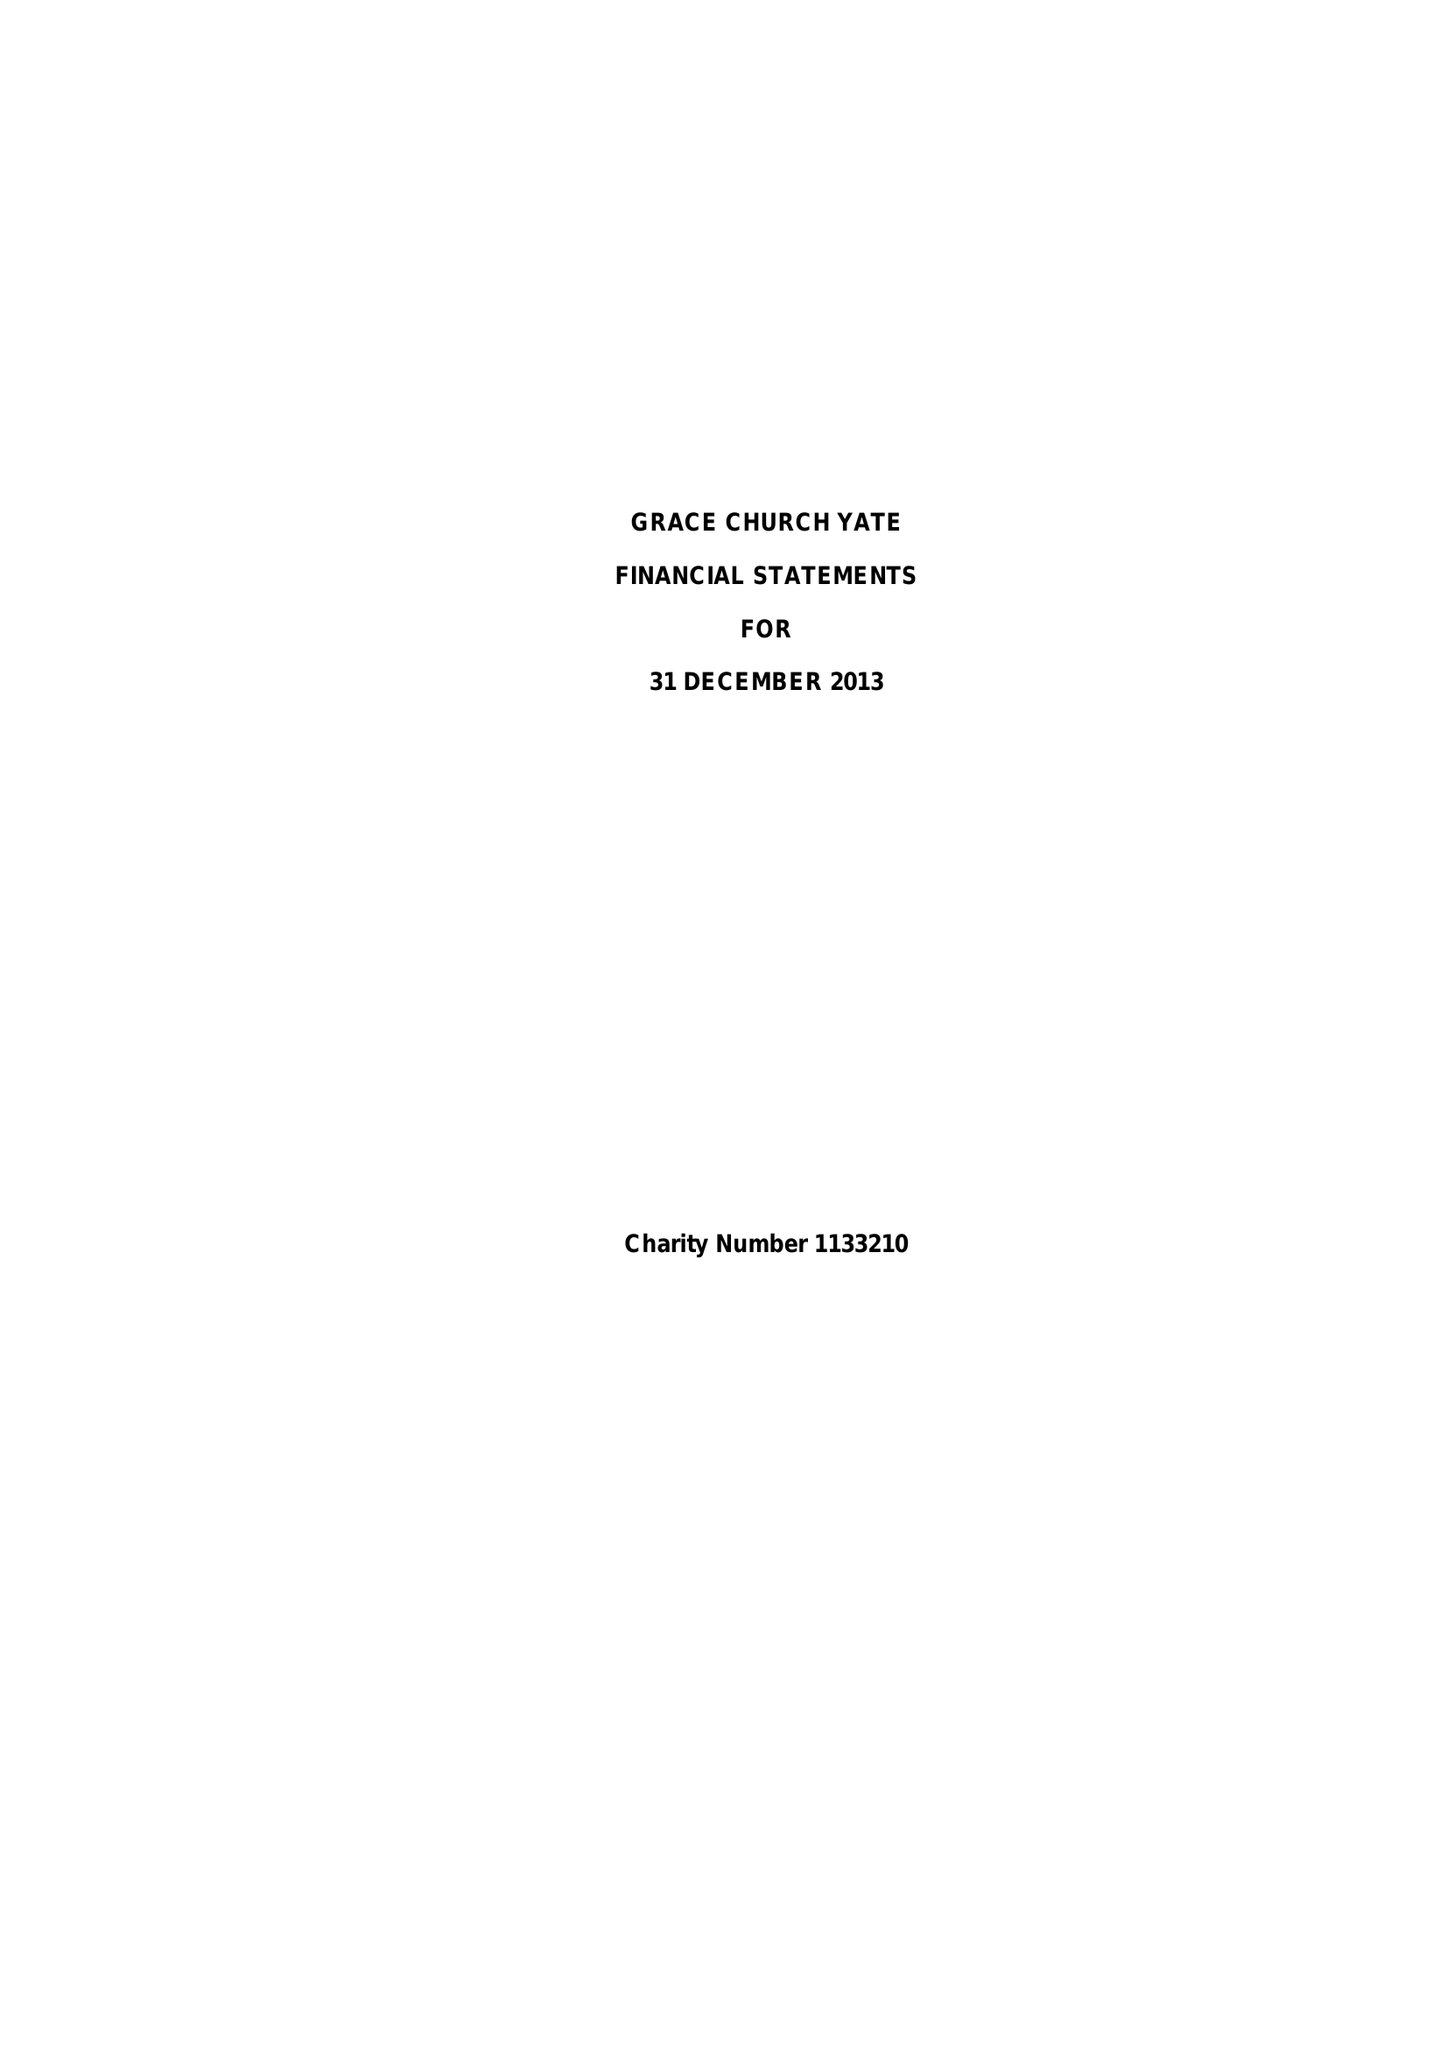What is the value for the charity_name?
Answer the question using a single word or phrase. Grace Church Yate 